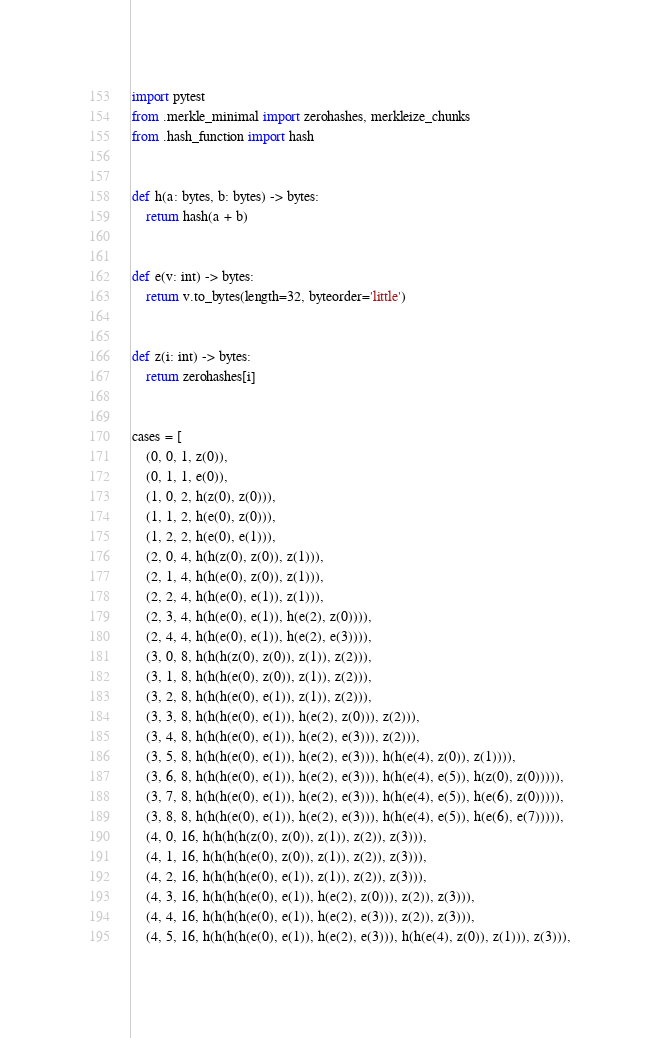Convert code to text. <code><loc_0><loc_0><loc_500><loc_500><_Python_>import pytest
from .merkle_minimal import zerohashes, merkleize_chunks
from .hash_function import hash


def h(a: bytes, b: bytes) -> bytes:
    return hash(a + b)


def e(v: int) -> bytes:
    return v.to_bytes(length=32, byteorder='little')


def z(i: int) -> bytes:
    return zerohashes[i]


cases = [
    (0, 0, 1, z(0)),
    (0, 1, 1, e(0)),
    (1, 0, 2, h(z(0), z(0))),
    (1, 1, 2, h(e(0), z(0))),
    (1, 2, 2, h(e(0), e(1))),
    (2, 0, 4, h(h(z(0), z(0)), z(1))),
    (2, 1, 4, h(h(e(0), z(0)), z(1))),
    (2, 2, 4, h(h(e(0), e(1)), z(1))),
    (2, 3, 4, h(h(e(0), e(1)), h(e(2), z(0)))),
    (2, 4, 4, h(h(e(0), e(1)), h(e(2), e(3)))),
    (3, 0, 8, h(h(h(z(0), z(0)), z(1)), z(2))),
    (3, 1, 8, h(h(h(e(0), z(0)), z(1)), z(2))),
    (3, 2, 8, h(h(h(e(0), e(1)), z(1)), z(2))),
    (3, 3, 8, h(h(h(e(0), e(1)), h(e(2), z(0))), z(2))),
    (3, 4, 8, h(h(h(e(0), e(1)), h(e(2), e(3))), z(2))),
    (3, 5, 8, h(h(h(e(0), e(1)), h(e(2), e(3))), h(h(e(4), z(0)), z(1)))),
    (3, 6, 8, h(h(h(e(0), e(1)), h(e(2), e(3))), h(h(e(4), e(5)), h(z(0), z(0))))),
    (3, 7, 8, h(h(h(e(0), e(1)), h(e(2), e(3))), h(h(e(4), e(5)), h(e(6), z(0))))),
    (3, 8, 8, h(h(h(e(0), e(1)), h(e(2), e(3))), h(h(e(4), e(5)), h(e(6), e(7))))),
    (4, 0, 16, h(h(h(h(z(0), z(0)), z(1)), z(2)), z(3))),
    (4, 1, 16, h(h(h(h(e(0), z(0)), z(1)), z(2)), z(3))),
    (4, 2, 16, h(h(h(h(e(0), e(1)), z(1)), z(2)), z(3))),
    (4, 3, 16, h(h(h(h(e(0), e(1)), h(e(2), z(0))), z(2)), z(3))),
    (4, 4, 16, h(h(h(h(e(0), e(1)), h(e(2), e(3))), z(2)), z(3))),
    (4, 5, 16, h(h(h(h(e(0), e(1)), h(e(2), e(3))), h(h(e(4), z(0)), z(1))), z(3))),</code> 